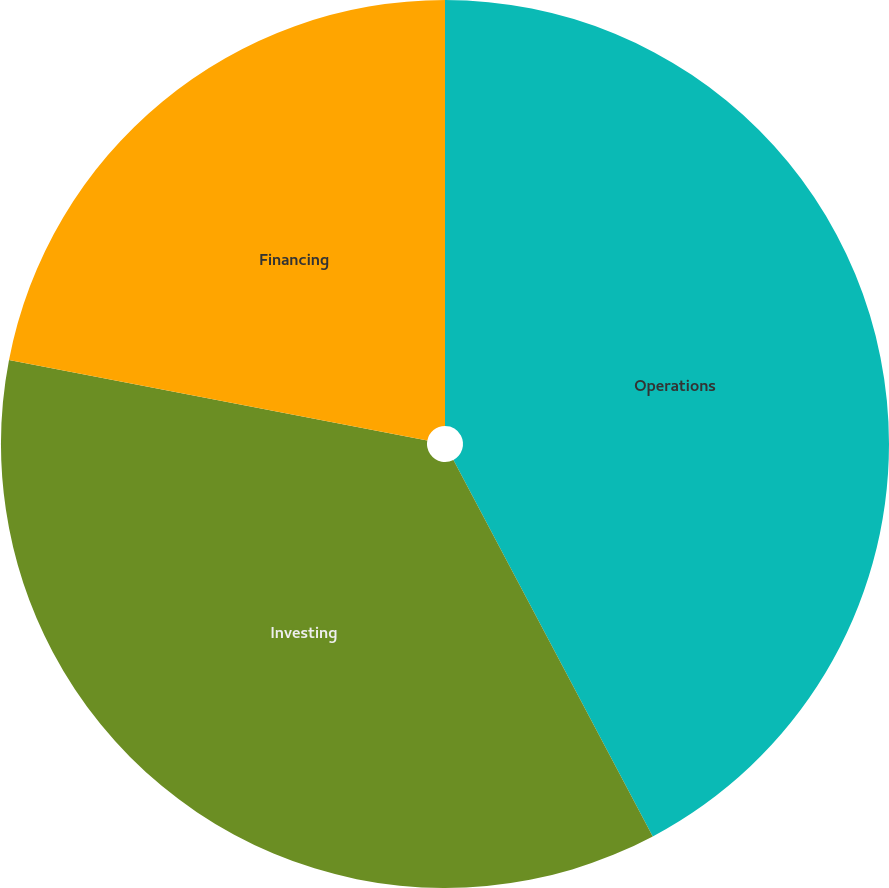Convert chart. <chart><loc_0><loc_0><loc_500><loc_500><pie_chart><fcel>Operations<fcel>Investing<fcel>Financing<nl><fcel>42.25%<fcel>35.78%<fcel>21.97%<nl></chart> 